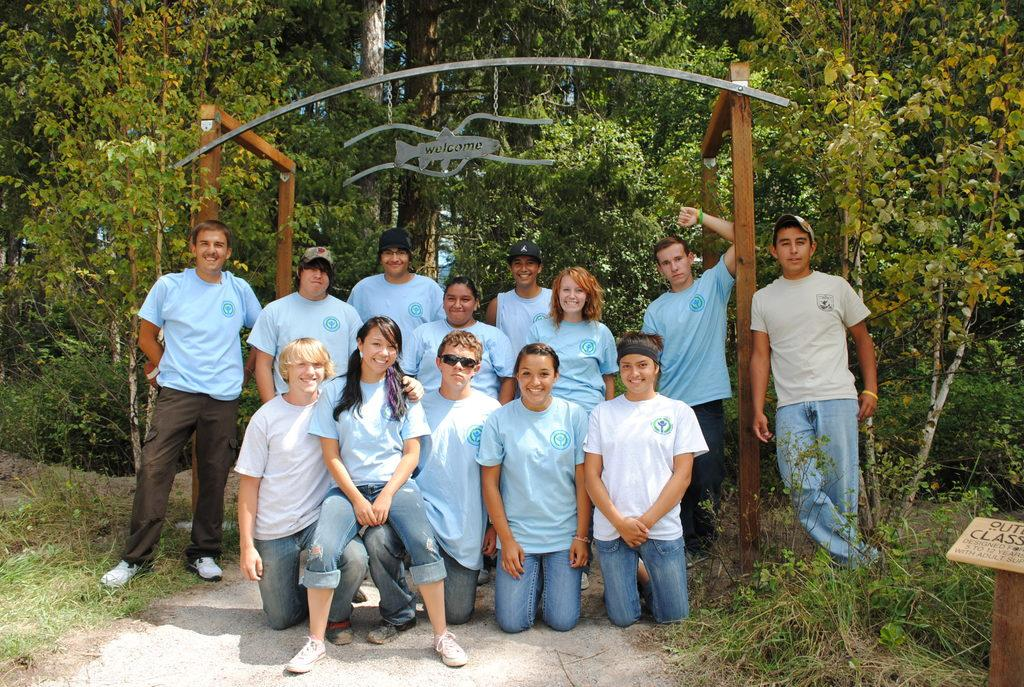What type of structure is visible in the image? There is an arch construction in the image. What natural elements can be seen in the image? There are trees and green grass in the image. How are the people in the image depicted? There are people with smiles in the image. What type of popcorn is being served at the event in the image? There is no event or popcorn present in the image; it features an arch construction, trees, green grass, and people with smiles. How many legs can be seen on the people in the image? The number of legs on the people in the image cannot be determined from the provided facts, as the focus is on their smiles and not their legs. 